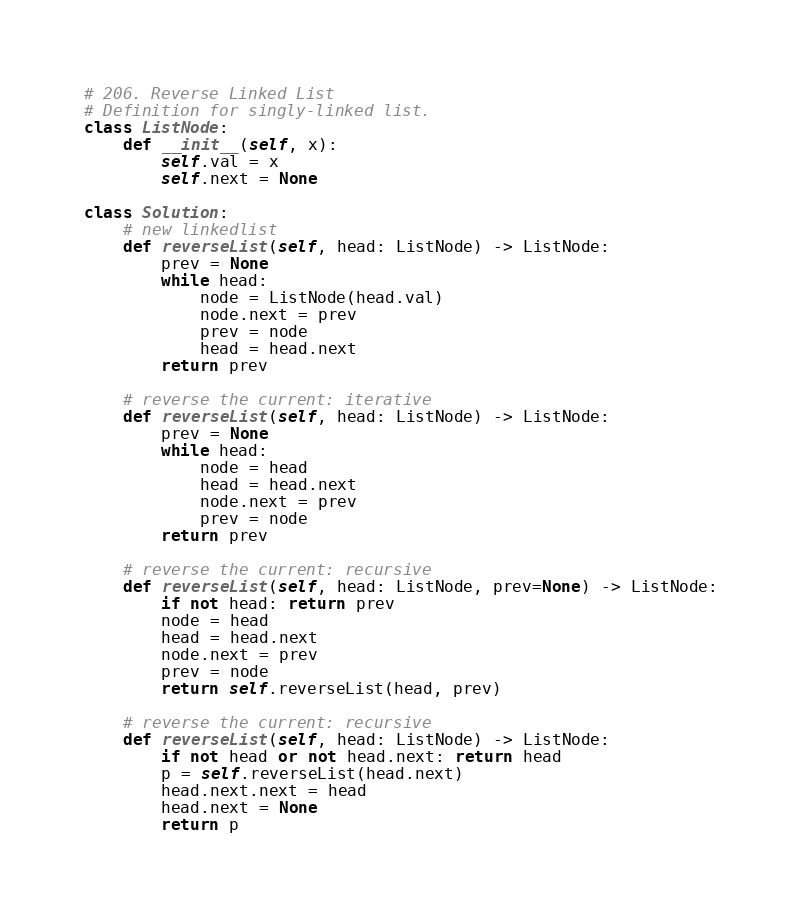<code> <loc_0><loc_0><loc_500><loc_500><_Python_># 206. Reverse Linked List
# Definition for singly-linked list.
class ListNode:
    def __init__(self, x):
        self.val = x
        self.next = None

class Solution:
    # new linkedlist
    def reverseList(self, head: ListNode) -> ListNode:
        prev = None
        while head:
            node = ListNode(head.val)
            node.next = prev
            prev = node
            head = head.next
        return prev

    # reverse the current: iterative
    def reverseList(self, head: ListNode) -> ListNode:
        prev = None
        while head:
            node = head
            head = head.next
            node.next = prev
            prev = node
        return prev

    # reverse the current: recursive
    def reverseList(self, head: ListNode, prev=None) -> ListNode:
        if not head: return prev
        node = head
        head = head.next
        node.next = prev
        prev = node
        return self.reverseList(head, prev)

    # reverse the current: recursive
    def reverseList(self, head: ListNode) -> ListNode:
        if not head or not head.next: return head
        p = self.reverseList(head.next)
        head.next.next = head
        head.next = None
        return p</code> 